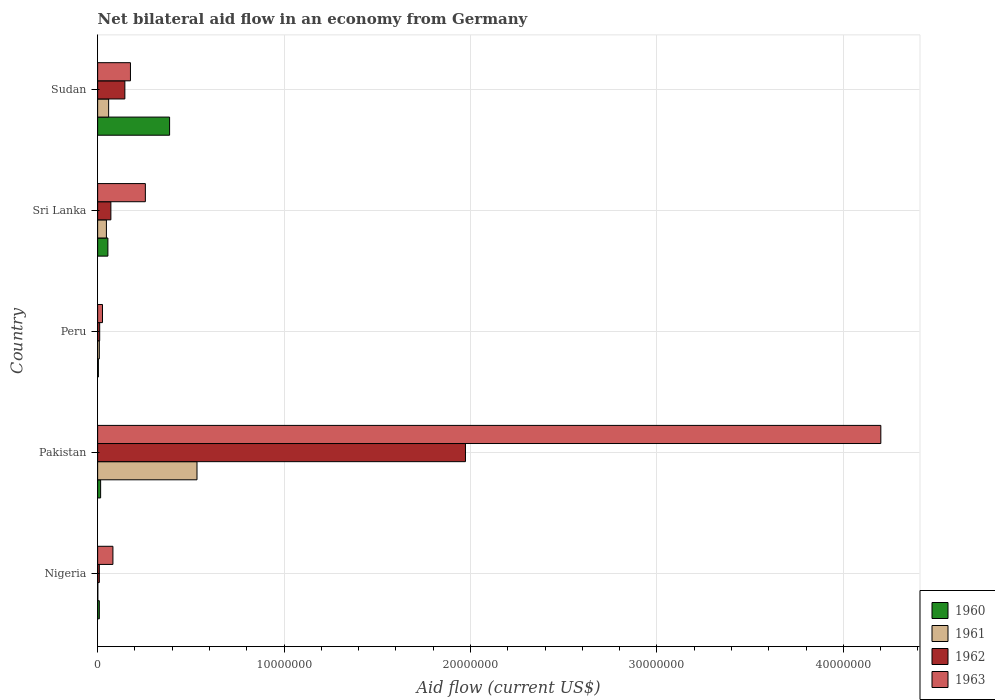How many different coloured bars are there?
Ensure brevity in your answer.  4. How many groups of bars are there?
Your answer should be compact. 5. Are the number of bars on each tick of the Y-axis equal?
Provide a short and direct response. Yes. How many bars are there on the 4th tick from the top?
Keep it short and to the point. 4. How many bars are there on the 5th tick from the bottom?
Make the answer very short. 4. What is the label of the 5th group of bars from the top?
Offer a terse response. Nigeria. In how many cases, is the number of bars for a given country not equal to the number of legend labels?
Offer a terse response. 0. Across all countries, what is the maximum net bilateral aid flow in 1961?
Make the answer very short. 5.33e+06. Across all countries, what is the minimum net bilateral aid flow in 1961?
Offer a terse response. 10000. In which country was the net bilateral aid flow in 1960 maximum?
Give a very brief answer. Sudan. In which country was the net bilateral aid flow in 1963 minimum?
Offer a very short reply. Peru. What is the total net bilateral aid flow in 1962 in the graph?
Provide a succinct answer. 2.21e+07. What is the difference between the net bilateral aid flow in 1962 in Pakistan and that in Sudan?
Offer a terse response. 1.83e+07. What is the difference between the net bilateral aid flow in 1962 in Sudan and the net bilateral aid flow in 1960 in Sri Lanka?
Give a very brief answer. 9.10e+05. What is the average net bilateral aid flow in 1960 per country?
Provide a short and direct response. 9.40e+05. What is the difference between the net bilateral aid flow in 1961 and net bilateral aid flow in 1963 in Pakistan?
Provide a short and direct response. -3.67e+07. In how many countries, is the net bilateral aid flow in 1961 greater than 20000000 US$?
Ensure brevity in your answer.  0. What is the ratio of the net bilateral aid flow in 1963 in Nigeria to that in Peru?
Provide a short and direct response. 3.15. What is the difference between the highest and the second highest net bilateral aid flow in 1962?
Offer a very short reply. 1.83e+07. What is the difference between the highest and the lowest net bilateral aid flow in 1961?
Ensure brevity in your answer.  5.32e+06. In how many countries, is the net bilateral aid flow in 1961 greater than the average net bilateral aid flow in 1961 taken over all countries?
Ensure brevity in your answer.  1. Is it the case that in every country, the sum of the net bilateral aid flow in 1960 and net bilateral aid flow in 1963 is greater than the sum of net bilateral aid flow in 1961 and net bilateral aid flow in 1962?
Your answer should be very brief. No. What does the 2nd bar from the bottom in Nigeria represents?
Your response must be concise. 1961. Is it the case that in every country, the sum of the net bilateral aid flow in 1963 and net bilateral aid flow in 1962 is greater than the net bilateral aid flow in 1961?
Ensure brevity in your answer.  Yes. How many bars are there?
Your response must be concise. 20. Are all the bars in the graph horizontal?
Your answer should be compact. Yes. Does the graph contain grids?
Your answer should be compact. Yes. How many legend labels are there?
Ensure brevity in your answer.  4. How are the legend labels stacked?
Make the answer very short. Vertical. What is the title of the graph?
Give a very brief answer. Net bilateral aid flow in an economy from Germany. Does "2002" appear as one of the legend labels in the graph?
Provide a succinct answer. No. What is the Aid flow (current US$) in 1963 in Nigeria?
Provide a short and direct response. 8.20e+05. What is the Aid flow (current US$) in 1960 in Pakistan?
Ensure brevity in your answer.  1.60e+05. What is the Aid flow (current US$) in 1961 in Pakistan?
Make the answer very short. 5.33e+06. What is the Aid flow (current US$) of 1962 in Pakistan?
Provide a succinct answer. 1.97e+07. What is the Aid flow (current US$) in 1963 in Pakistan?
Offer a terse response. 4.20e+07. What is the Aid flow (current US$) of 1961 in Peru?
Offer a very short reply. 9.00e+04. What is the Aid flow (current US$) in 1963 in Peru?
Make the answer very short. 2.60e+05. What is the Aid flow (current US$) in 1961 in Sri Lanka?
Make the answer very short. 4.70e+05. What is the Aid flow (current US$) in 1962 in Sri Lanka?
Offer a very short reply. 7.10e+05. What is the Aid flow (current US$) in 1963 in Sri Lanka?
Give a very brief answer. 2.56e+06. What is the Aid flow (current US$) in 1960 in Sudan?
Your answer should be compact. 3.86e+06. What is the Aid flow (current US$) of 1961 in Sudan?
Your answer should be compact. 5.90e+05. What is the Aid flow (current US$) of 1962 in Sudan?
Your answer should be compact. 1.46e+06. What is the Aid flow (current US$) in 1963 in Sudan?
Your answer should be very brief. 1.76e+06. Across all countries, what is the maximum Aid flow (current US$) in 1960?
Offer a very short reply. 3.86e+06. Across all countries, what is the maximum Aid flow (current US$) of 1961?
Your answer should be very brief. 5.33e+06. Across all countries, what is the maximum Aid flow (current US$) of 1962?
Give a very brief answer. 1.97e+07. Across all countries, what is the maximum Aid flow (current US$) of 1963?
Offer a very short reply. 4.20e+07. Across all countries, what is the minimum Aid flow (current US$) of 1962?
Ensure brevity in your answer.  9.00e+04. What is the total Aid flow (current US$) of 1960 in the graph?
Ensure brevity in your answer.  4.70e+06. What is the total Aid flow (current US$) of 1961 in the graph?
Offer a terse response. 6.49e+06. What is the total Aid flow (current US$) of 1962 in the graph?
Make the answer very short. 2.21e+07. What is the total Aid flow (current US$) of 1963 in the graph?
Provide a succinct answer. 4.74e+07. What is the difference between the Aid flow (current US$) in 1961 in Nigeria and that in Pakistan?
Your response must be concise. -5.32e+06. What is the difference between the Aid flow (current US$) in 1962 in Nigeria and that in Pakistan?
Your response must be concise. -1.96e+07. What is the difference between the Aid flow (current US$) of 1963 in Nigeria and that in Pakistan?
Offer a very short reply. -4.12e+07. What is the difference between the Aid flow (current US$) in 1963 in Nigeria and that in Peru?
Your response must be concise. 5.60e+05. What is the difference between the Aid flow (current US$) in 1960 in Nigeria and that in Sri Lanka?
Keep it short and to the point. -4.60e+05. What is the difference between the Aid flow (current US$) in 1961 in Nigeria and that in Sri Lanka?
Give a very brief answer. -4.60e+05. What is the difference between the Aid flow (current US$) in 1962 in Nigeria and that in Sri Lanka?
Your answer should be compact. -6.20e+05. What is the difference between the Aid flow (current US$) of 1963 in Nigeria and that in Sri Lanka?
Your answer should be compact. -1.74e+06. What is the difference between the Aid flow (current US$) of 1960 in Nigeria and that in Sudan?
Make the answer very short. -3.77e+06. What is the difference between the Aid flow (current US$) in 1961 in Nigeria and that in Sudan?
Provide a short and direct response. -5.80e+05. What is the difference between the Aid flow (current US$) of 1962 in Nigeria and that in Sudan?
Keep it short and to the point. -1.37e+06. What is the difference between the Aid flow (current US$) in 1963 in Nigeria and that in Sudan?
Your answer should be compact. -9.40e+05. What is the difference between the Aid flow (current US$) in 1961 in Pakistan and that in Peru?
Offer a terse response. 5.24e+06. What is the difference between the Aid flow (current US$) of 1962 in Pakistan and that in Peru?
Provide a succinct answer. 1.96e+07. What is the difference between the Aid flow (current US$) of 1963 in Pakistan and that in Peru?
Provide a short and direct response. 4.18e+07. What is the difference between the Aid flow (current US$) of 1960 in Pakistan and that in Sri Lanka?
Provide a short and direct response. -3.90e+05. What is the difference between the Aid flow (current US$) in 1961 in Pakistan and that in Sri Lanka?
Offer a very short reply. 4.86e+06. What is the difference between the Aid flow (current US$) in 1962 in Pakistan and that in Sri Lanka?
Keep it short and to the point. 1.90e+07. What is the difference between the Aid flow (current US$) of 1963 in Pakistan and that in Sri Lanka?
Offer a very short reply. 3.94e+07. What is the difference between the Aid flow (current US$) in 1960 in Pakistan and that in Sudan?
Offer a terse response. -3.70e+06. What is the difference between the Aid flow (current US$) of 1961 in Pakistan and that in Sudan?
Make the answer very short. 4.74e+06. What is the difference between the Aid flow (current US$) in 1962 in Pakistan and that in Sudan?
Your answer should be compact. 1.83e+07. What is the difference between the Aid flow (current US$) in 1963 in Pakistan and that in Sudan?
Ensure brevity in your answer.  4.02e+07. What is the difference between the Aid flow (current US$) in 1960 in Peru and that in Sri Lanka?
Give a very brief answer. -5.10e+05. What is the difference between the Aid flow (current US$) in 1961 in Peru and that in Sri Lanka?
Give a very brief answer. -3.80e+05. What is the difference between the Aid flow (current US$) of 1962 in Peru and that in Sri Lanka?
Keep it short and to the point. -6.00e+05. What is the difference between the Aid flow (current US$) of 1963 in Peru and that in Sri Lanka?
Your answer should be very brief. -2.30e+06. What is the difference between the Aid flow (current US$) in 1960 in Peru and that in Sudan?
Your response must be concise. -3.82e+06. What is the difference between the Aid flow (current US$) in 1961 in Peru and that in Sudan?
Your response must be concise. -5.00e+05. What is the difference between the Aid flow (current US$) in 1962 in Peru and that in Sudan?
Offer a terse response. -1.35e+06. What is the difference between the Aid flow (current US$) of 1963 in Peru and that in Sudan?
Ensure brevity in your answer.  -1.50e+06. What is the difference between the Aid flow (current US$) of 1960 in Sri Lanka and that in Sudan?
Provide a succinct answer. -3.31e+06. What is the difference between the Aid flow (current US$) of 1962 in Sri Lanka and that in Sudan?
Provide a succinct answer. -7.50e+05. What is the difference between the Aid flow (current US$) in 1960 in Nigeria and the Aid flow (current US$) in 1961 in Pakistan?
Provide a succinct answer. -5.24e+06. What is the difference between the Aid flow (current US$) in 1960 in Nigeria and the Aid flow (current US$) in 1962 in Pakistan?
Ensure brevity in your answer.  -1.96e+07. What is the difference between the Aid flow (current US$) of 1960 in Nigeria and the Aid flow (current US$) of 1963 in Pakistan?
Provide a short and direct response. -4.19e+07. What is the difference between the Aid flow (current US$) in 1961 in Nigeria and the Aid flow (current US$) in 1962 in Pakistan?
Make the answer very short. -1.97e+07. What is the difference between the Aid flow (current US$) of 1961 in Nigeria and the Aid flow (current US$) of 1963 in Pakistan?
Make the answer very short. -4.20e+07. What is the difference between the Aid flow (current US$) of 1962 in Nigeria and the Aid flow (current US$) of 1963 in Pakistan?
Offer a terse response. -4.19e+07. What is the difference between the Aid flow (current US$) in 1960 in Nigeria and the Aid flow (current US$) in 1961 in Peru?
Ensure brevity in your answer.  0. What is the difference between the Aid flow (current US$) of 1960 in Nigeria and the Aid flow (current US$) of 1962 in Peru?
Your answer should be very brief. -2.00e+04. What is the difference between the Aid flow (current US$) of 1960 in Nigeria and the Aid flow (current US$) of 1963 in Peru?
Offer a terse response. -1.70e+05. What is the difference between the Aid flow (current US$) of 1962 in Nigeria and the Aid flow (current US$) of 1963 in Peru?
Give a very brief answer. -1.70e+05. What is the difference between the Aid flow (current US$) in 1960 in Nigeria and the Aid flow (current US$) in 1961 in Sri Lanka?
Provide a short and direct response. -3.80e+05. What is the difference between the Aid flow (current US$) of 1960 in Nigeria and the Aid flow (current US$) of 1962 in Sri Lanka?
Ensure brevity in your answer.  -6.20e+05. What is the difference between the Aid flow (current US$) of 1960 in Nigeria and the Aid flow (current US$) of 1963 in Sri Lanka?
Offer a terse response. -2.47e+06. What is the difference between the Aid flow (current US$) of 1961 in Nigeria and the Aid flow (current US$) of 1962 in Sri Lanka?
Provide a short and direct response. -7.00e+05. What is the difference between the Aid flow (current US$) of 1961 in Nigeria and the Aid flow (current US$) of 1963 in Sri Lanka?
Your answer should be compact. -2.55e+06. What is the difference between the Aid flow (current US$) in 1962 in Nigeria and the Aid flow (current US$) in 1963 in Sri Lanka?
Your answer should be compact. -2.47e+06. What is the difference between the Aid flow (current US$) in 1960 in Nigeria and the Aid flow (current US$) in 1961 in Sudan?
Keep it short and to the point. -5.00e+05. What is the difference between the Aid flow (current US$) in 1960 in Nigeria and the Aid flow (current US$) in 1962 in Sudan?
Your answer should be compact. -1.37e+06. What is the difference between the Aid flow (current US$) in 1960 in Nigeria and the Aid flow (current US$) in 1963 in Sudan?
Offer a very short reply. -1.67e+06. What is the difference between the Aid flow (current US$) in 1961 in Nigeria and the Aid flow (current US$) in 1962 in Sudan?
Give a very brief answer. -1.45e+06. What is the difference between the Aid flow (current US$) of 1961 in Nigeria and the Aid flow (current US$) of 1963 in Sudan?
Make the answer very short. -1.75e+06. What is the difference between the Aid flow (current US$) in 1962 in Nigeria and the Aid flow (current US$) in 1963 in Sudan?
Your answer should be very brief. -1.67e+06. What is the difference between the Aid flow (current US$) of 1960 in Pakistan and the Aid flow (current US$) of 1963 in Peru?
Your answer should be compact. -1.00e+05. What is the difference between the Aid flow (current US$) in 1961 in Pakistan and the Aid flow (current US$) in 1962 in Peru?
Give a very brief answer. 5.22e+06. What is the difference between the Aid flow (current US$) in 1961 in Pakistan and the Aid flow (current US$) in 1963 in Peru?
Offer a very short reply. 5.07e+06. What is the difference between the Aid flow (current US$) in 1962 in Pakistan and the Aid flow (current US$) in 1963 in Peru?
Provide a succinct answer. 1.95e+07. What is the difference between the Aid flow (current US$) of 1960 in Pakistan and the Aid flow (current US$) of 1961 in Sri Lanka?
Offer a terse response. -3.10e+05. What is the difference between the Aid flow (current US$) of 1960 in Pakistan and the Aid flow (current US$) of 1962 in Sri Lanka?
Make the answer very short. -5.50e+05. What is the difference between the Aid flow (current US$) in 1960 in Pakistan and the Aid flow (current US$) in 1963 in Sri Lanka?
Your answer should be very brief. -2.40e+06. What is the difference between the Aid flow (current US$) of 1961 in Pakistan and the Aid flow (current US$) of 1962 in Sri Lanka?
Your answer should be compact. 4.62e+06. What is the difference between the Aid flow (current US$) in 1961 in Pakistan and the Aid flow (current US$) in 1963 in Sri Lanka?
Keep it short and to the point. 2.77e+06. What is the difference between the Aid flow (current US$) in 1962 in Pakistan and the Aid flow (current US$) in 1963 in Sri Lanka?
Provide a short and direct response. 1.72e+07. What is the difference between the Aid flow (current US$) of 1960 in Pakistan and the Aid flow (current US$) of 1961 in Sudan?
Offer a terse response. -4.30e+05. What is the difference between the Aid flow (current US$) in 1960 in Pakistan and the Aid flow (current US$) in 1962 in Sudan?
Provide a short and direct response. -1.30e+06. What is the difference between the Aid flow (current US$) in 1960 in Pakistan and the Aid flow (current US$) in 1963 in Sudan?
Your answer should be very brief. -1.60e+06. What is the difference between the Aid flow (current US$) in 1961 in Pakistan and the Aid flow (current US$) in 1962 in Sudan?
Provide a short and direct response. 3.87e+06. What is the difference between the Aid flow (current US$) in 1961 in Pakistan and the Aid flow (current US$) in 1963 in Sudan?
Your answer should be compact. 3.57e+06. What is the difference between the Aid flow (current US$) in 1962 in Pakistan and the Aid flow (current US$) in 1963 in Sudan?
Offer a terse response. 1.80e+07. What is the difference between the Aid flow (current US$) in 1960 in Peru and the Aid flow (current US$) in 1961 in Sri Lanka?
Your answer should be compact. -4.30e+05. What is the difference between the Aid flow (current US$) in 1960 in Peru and the Aid flow (current US$) in 1962 in Sri Lanka?
Your answer should be very brief. -6.70e+05. What is the difference between the Aid flow (current US$) in 1960 in Peru and the Aid flow (current US$) in 1963 in Sri Lanka?
Your answer should be compact. -2.52e+06. What is the difference between the Aid flow (current US$) in 1961 in Peru and the Aid flow (current US$) in 1962 in Sri Lanka?
Give a very brief answer. -6.20e+05. What is the difference between the Aid flow (current US$) in 1961 in Peru and the Aid flow (current US$) in 1963 in Sri Lanka?
Offer a terse response. -2.47e+06. What is the difference between the Aid flow (current US$) in 1962 in Peru and the Aid flow (current US$) in 1963 in Sri Lanka?
Make the answer very short. -2.45e+06. What is the difference between the Aid flow (current US$) of 1960 in Peru and the Aid flow (current US$) of 1961 in Sudan?
Provide a short and direct response. -5.50e+05. What is the difference between the Aid flow (current US$) of 1960 in Peru and the Aid flow (current US$) of 1962 in Sudan?
Provide a short and direct response. -1.42e+06. What is the difference between the Aid flow (current US$) of 1960 in Peru and the Aid flow (current US$) of 1963 in Sudan?
Offer a very short reply. -1.72e+06. What is the difference between the Aid flow (current US$) in 1961 in Peru and the Aid flow (current US$) in 1962 in Sudan?
Ensure brevity in your answer.  -1.37e+06. What is the difference between the Aid flow (current US$) of 1961 in Peru and the Aid flow (current US$) of 1963 in Sudan?
Offer a terse response. -1.67e+06. What is the difference between the Aid flow (current US$) of 1962 in Peru and the Aid flow (current US$) of 1963 in Sudan?
Your answer should be compact. -1.65e+06. What is the difference between the Aid flow (current US$) in 1960 in Sri Lanka and the Aid flow (current US$) in 1962 in Sudan?
Your answer should be very brief. -9.10e+05. What is the difference between the Aid flow (current US$) in 1960 in Sri Lanka and the Aid flow (current US$) in 1963 in Sudan?
Your response must be concise. -1.21e+06. What is the difference between the Aid flow (current US$) in 1961 in Sri Lanka and the Aid flow (current US$) in 1962 in Sudan?
Offer a very short reply. -9.90e+05. What is the difference between the Aid flow (current US$) of 1961 in Sri Lanka and the Aid flow (current US$) of 1963 in Sudan?
Your answer should be very brief. -1.29e+06. What is the difference between the Aid flow (current US$) of 1962 in Sri Lanka and the Aid flow (current US$) of 1963 in Sudan?
Offer a very short reply. -1.05e+06. What is the average Aid flow (current US$) in 1960 per country?
Ensure brevity in your answer.  9.40e+05. What is the average Aid flow (current US$) in 1961 per country?
Offer a very short reply. 1.30e+06. What is the average Aid flow (current US$) in 1962 per country?
Give a very brief answer. 4.42e+06. What is the average Aid flow (current US$) in 1963 per country?
Keep it short and to the point. 9.48e+06. What is the difference between the Aid flow (current US$) in 1960 and Aid flow (current US$) in 1962 in Nigeria?
Keep it short and to the point. 0. What is the difference between the Aid flow (current US$) in 1960 and Aid flow (current US$) in 1963 in Nigeria?
Your answer should be very brief. -7.30e+05. What is the difference between the Aid flow (current US$) in 1961 and Aid flow (current US$) in 1963 in Nigeria?
Ensure brevity in your answer.  -8.10e+05. What is the difference between the Aid flow (current US$) in 1962 and Aid flow (current US$) in 1963 in Nigeria?
Give a very brief answer. -7.30e+05. What is the difference between the Aid flow (current US$) of 1960 and Aid flow (current US$) of 1961 in Pakistan?
Keep it short and to the point. -5.17e+06. What is the difference between the Aid flow (current US$) of 1960 and Aid flow (current US$) of 1962 in Pakistan?
Make the answer very short. -1.96e+07. What is the difference between the Aid flow (current US$) in 1960 and Aid flow (current US$) in 1963 in Pakistan?
Ensure brevity in your answer.  -4.18e+07. What is the difference between the Aid flow (current US$) in 1961 and Aid flow (current US$) in 1962 in Pakistan?
Your answer should be compact. -1.44e+07. What is the difference between the Aid flow (current US$) in 1961 and Aid flow (current US$) in 1963 in Pakistan?
Offer a very short reply. -3.67e+07. What is the difference between the Aid flow (current US$) in 1962 and Aid flow (current US$) in 1963 in Pakistan?
Your answer should be very brief. -2.23e+07. What is the difference between the Aid flow (current US$) in 1960 and Aid flow (current US$) in 1961 in Peru?
Offer a terse response. -5.00e+04. What is the difference between the Aid flow (current US$) of 1960 and Aid flow (current US$) of 1961 in Sri Lanka?
Make the answer very short. 8.00e+04. What is the difference between the Aid flow (current US$) of 1960 and Aid flow (current US$) of 1963 in Sri Lanka?
Your answer should be very brief. -2.01e+06. What is the difference between the Aid flow (current US$) of 1961 and Aid flow (current US$) of 1962 in Sri Lanka?
Your answer should be very brief. -2.40e+05. What is the difference between the Aid flow (current US$) of 1961 and Aid flow (current US$) of 1963 in Sri Lanka?
Your response must be concise. -2.09e+06. What is the difference between the Aid flow (current US$) in 1962 and Aid flow (current US$) in 1963 in Sri Lanka?
Make the answer very short. -1.85e+06. What is the difference between the Aid flow (current US$) of 1960 and Aid flow (current US$) of 1961 in Sudan?
Provide a succinct answer. 3.27e+06. What is the difference between the Aid flow (current US$) of 1960 and Aid flow (current US$) of 1962 in Sudan?
Keep it short and to the point. 2.40e+06. What is the difference between the Aid flow (current US$) in 1960 and Aid flow (current US$) in 1963 in Sudan?
Your answer should be compact. 2.10e+06. What is the difference between the Aid flow (current US$) in 1961 and Aid flow (current US$) in 1962 in Sudan?
Provide a short and direct response. -8.70e+05. What is the difference between the Aid flow (current US$) of 1961 and Aid flow (current US$) of 1963 in Sudan?
Offer a terse response. -1.17e+06. What is the ratio of the Aid flow (current US$) in 1960 in Nigeria to that in Pakistan?
Keep it short and to the point. 0.56. What is the ratio of the Aid flow (current US$) of 1961 in Nigeria to that in Pakistan?
Your answer should be compact. 0. What is the ratio of the Aid flow (current US$) in 1962 in Nigeria to that in Pakistan?
Your response must be concise. 0. What is the ratio of the Aid flow (current US$) of 1963 in Nigeria to that in Pakistan?
Offer a very short reply. 0.02. What is the ratio of the Aid flow (current US$) in 1960 in Nigeria to that in Peru?
Offer a very short reply. 2.25. What is the ratio of the Aid flow (current US$) of 1962 in Nigeria to that in Peru?
Your answer should be very brief. 0.82. What is the ratio of the Aid flow (current US$) in 1963 in Nigeria to that in Peru?
Provide a succinct answer. 3.15. What is the ratio of the Aid flow (current US$) in 1960 in Nigeria to that in Sri Lanka?
Offer a very short reply. 0.16. What is the ratio of the Aid flow (current US$) of 1961 in Nigeria to that in Sri Lanka?
Offer a terse response. 0.02. What is the ratio of the Aid flow (current US$) in 1962 in Nigeria to that in Sri Lanka?
Your answer should be compact. 0.13. What is the ratio of the Aid flow (current US$) of 1963 in Nigeria to that in Sri Lanka?
Give a very brief answer. 0.32. What is the ratio of the Aid flow (current US$) in 1960 in Nigeria to that in Sudan?
Give a very brief answer. 0.02. What is the ratio of the Aid flow (current US$) in 1961 in Nigeria to that in Sudan?
Offer a very short reply. 0.02. What is the ratio of the Aid flow (current US$) in 1962 in Nigeria to that in Sudan?
Make the answer very short. 0.06. What is the ratio of the Aid flow (current US$) of 1963 in Nigeria to that in Sudan?
Offer a terse response. 0.47. What is the ratio of the Aid flow (current US$) in 1961 in Pakistan to that in Peru?
Give a very brief answer. 59.22. What is the ratio of the Aid flow (current US$) in 1962 in Pakistan to that in Peru?
Offer a very short reply. 179.36. What is the ratio of the Aid flow (current US$) in 1963 in Pakistan to that in Peru?
Make the answer very short. 161.58. What is the ratio of the Aid flow (current US$) in 1960 in Pakistan to that in Sri Lanka?
Your answer should be very brief. 0.29. What is the ratio of the Aid flow (current US$) of 1961 in Pakistan to that in Sri Lanka?
Provide a succinct answer. 11.34. What is the ratio of the Aid flow (current US$) in 1962 in Pakistan to that in Sri Lanka?
Your response must be concise. 27.79. What is the ratio of the Aid flow (current US$) in 1963 in Pakistan to that in Sri Lanka?
Keep it short and to the point. 16.41. What is the ratio of the Aid flow (current US$) of 1960 in Pakistan to that in Sudan?
Your answer should be very brief. 0.04. What is the ratio of the Aid flow (current US$) of 1961 in Pakistan to that in Sudan?
Provide a short and direct response. 9.03. What is the ratio of the Aid flow (current US$) in 1962 in Pakistan to that in Sudan?
Offer a terse response. 13.51. What is the ratio of the Aid flow (current US$) in 1963 in Pakistan to that in Sudan?
Offer a terse response. 23.87. What is the ratio of the Aid flow (current US$) of 1960 in Peru to that in Sri Lanka?
Give a very brief answer. 0.07. What is the ratio of the Aid flow (current US$) in 1961 in Peru to that in Sri Lanka?
Keep it short and to the point. 0.19. What is the ratio of the Aid flow (current US$) in 1962 in Peru to that in Sri Lanka?
Provide a short and direct response. 0.15. What is the ratio of the Aid flow (current US$) of 1963 in Peru to that in Sri Lanka?
Make the answer very short. 0.1. What is the ratio of the Aid flow (current US$) of 1960 in Peru to that in Sudan?
Keep it short and to the point. 0.01. What is the ratio of the Aid flow (current US$) of 1961 in Peru to that in Sudan?
Make the answer very short. 0.15. What is the ratio of the Aid flow (current US$) in 1962 in Peru to that in Sudan?
Keep it short and to the point. 0.08. What is the ratio of the Aid flow (current US$) in 1963 in Peru to that in Sudan?
Ensure brevity in your answer.  0.15. What is the ratio of the Aid flow (current US$) in 1960 in Sri Lanka to that in Sudan?
Your answer should be very brief. 0.14. What is the ratio of the Aid flow (current US$) in 1961 in Sri Lanka to that in Sudan?
Your answer should be compact. 0.8. What is the ratio of the Aid flow (current US$) of 1962 in Sri Lanka to that in Sudan?
Your answer should be compact. 0.49. What is the ratio of the Aid flow (current US$) in 1963 in Sri Lanka to that in Sudan?
Provide a short and direct response. 1.45. What is the difference between the highest and the second highest Aid flow (current US$) of 1960?
Your answer should be compact. 3.31e+06. What is the difference between the highest and the second highest Aid flow (current US$) of 1961?
Give a very brief answer. 4.74e+06. What is the difference between the highest and the second highest Aid flow (current US$) of 1962?
Provide a short and direct response. 1.83e+07. What is the difference between the highest and the second highest Aid flow (current US$) in 1963?
Provide a succinct answer. 3.94e+07. What is the difference between the highest and the lowest Aid flow (current US$) in 1960?
Your response must be concise. 3.82e+06. What is the difference between the highest and the lowest Aid flow (current US$) in 1961?
Your response must be concise. 5.32e+06. What is the difference between the highest and the lowest Aid flow (current US$) in 1962?
Ensure brevity in your answer.  1.96e+07. What is the difference between the highest and the lowest Aid flow (current US$) of 1963?
Give a very brief answer. 4.18e+07. 